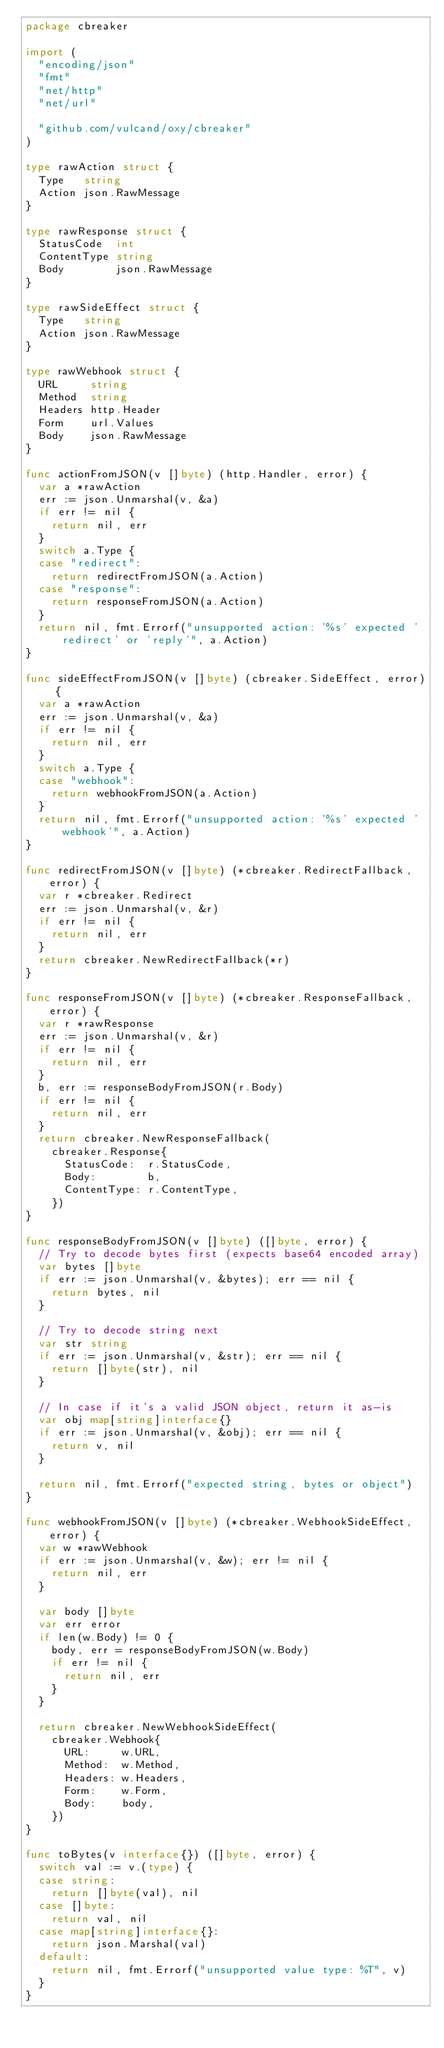Convert code to text. <code><loc_0><loc_0><loc_500><loc_500><_Go_>package cbreaker

import (
	"encoding/json"
	"fmt"
	"net/http"
	"net/url"

	"github.com/vulcand/oxy/cbreaker"
)

type rawAction struct {
	Type   string
	Action json.RawMessage
}

type rawResponse struct {
	StatusCode  int
	ContentType string
	Body        json.RawMessage
}

type rawSideEffect struct {
	Type   string
	Action json.RawMessage
}

type rawWebhook struct {
	URL     string
	Method  string
	Headers http.Header
	Form    url.Values
	Body    json.RawMessage
}

func actionFromJSON(v []byte) (http.Handler, error) {
	var a *rawAction
	err := json.Unmarshal(v, &a)
	if err != nil {
		return nil, err
	}
	switch a.Type {
	case "redirect":
		return redirectFromJSON(a.Action)
	case "response":
		return responseFromJSON(a.Action)
	}
	return nil, fmt.Errorf("unsupported action: '%s' expected 'redirect' or 'reply'", a.Action)
}

func sideEffectFromJSON(v []byte) (cbreaker.SideEffect, error) {
	var a *rawAction
	err := json.Unmarshal(v, &a)
	if err != nil {
		return nil, err
	}
	switch a.Type {
	case "webhook":
		return webhookFromJSON(a.Action)
	}
	return nil, fmt.Errorf("unsupported action: '%s' expected 'webhook'", a.Action)
}

func redirectFromJSON(v []byte) (*cbreaker.RedirectFallback, error) {
	var r *cbreaker.Redirect
	err := json.Unmarshal(v, &r)
	if err != nil {
		return nil, err
	}
	return cbreaker.NewRedirectFallback(*r)
}

func responseFromJSON(v []byte) (*cbreaker.ResponseFallback, error) {
	var r *rawResponse
	err := json.Unmarshal(v, &r)
	if err != nil {
		return nil, err
	}
	b, err := responseBodyFromJSON(r.Body)
	if err != nil {
		return nil, err
	}
	return cbreaker.NewResponseFallback(
		cbreaker.Response{
			StatusCode:  r.StatusCode,
			Body:        b,
			ContentType: r.ContentType,
		})
}

func responseBodyFromJSON(v []byte) ([]byte, error) {
	// Try to decode bytes first (expects base64 encoded array)
	var bytes []byte
	if err := json.Unmarshal(v, &bytes); err == nil {
		return bytes, nil
	}

	// Try to decode string next
	var str string
	if err := json.Unmarshal(v, &str); err == nil {
		return []byte(str), nil
	}

	// In case if it's a valid JSON object, return it as-is
	var obj map[string]interface{}
	if err := json.Unmarshal(v, &obj); err == nil {
		return v, nil
	}

	return nil, fmt.Errorf("expected string, bytes or object")
}

func webhookFromJSON(v []byte) (*cbreaker.WebhookSideEffect, error) {
	var w *rawWebhook
	if err := json.Unmarshal(v, &w); err != nil {
		return nil, err
	}

	var body []byte
	var err error
	if len(w.Body) != 0 {
		body, err = responseBodyFromJSON(w.Body)
		if err != nil {
			return nil, err
		}
	}

	return cbreaker.NewWebhookSideEffect(
		cbreaker.Webhook{
			URL:     w.URL,
			Method:  w.Method,
			Headers: w.Headers,
			Form:    w.Form,
			Body:    body,
		})
}

func toBytes(v interface{}) ([]byte, error) {
	switch val := v.(type) {
	case string:
		return []byte(val), nil
	case []byte:
		return val, nil
	case map[string]interface{}:
		return json.Marshal(val)
	default:
		return nil, fmt.Errorf("unsupported value type: %T", v)
	}
}
</code> 